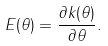<formula> <loc_0><loc_0><loc_500><loc_500>E ( \theta ) = \frac { \partial k ( \theta ) } { \partial \theta } .</formula> 